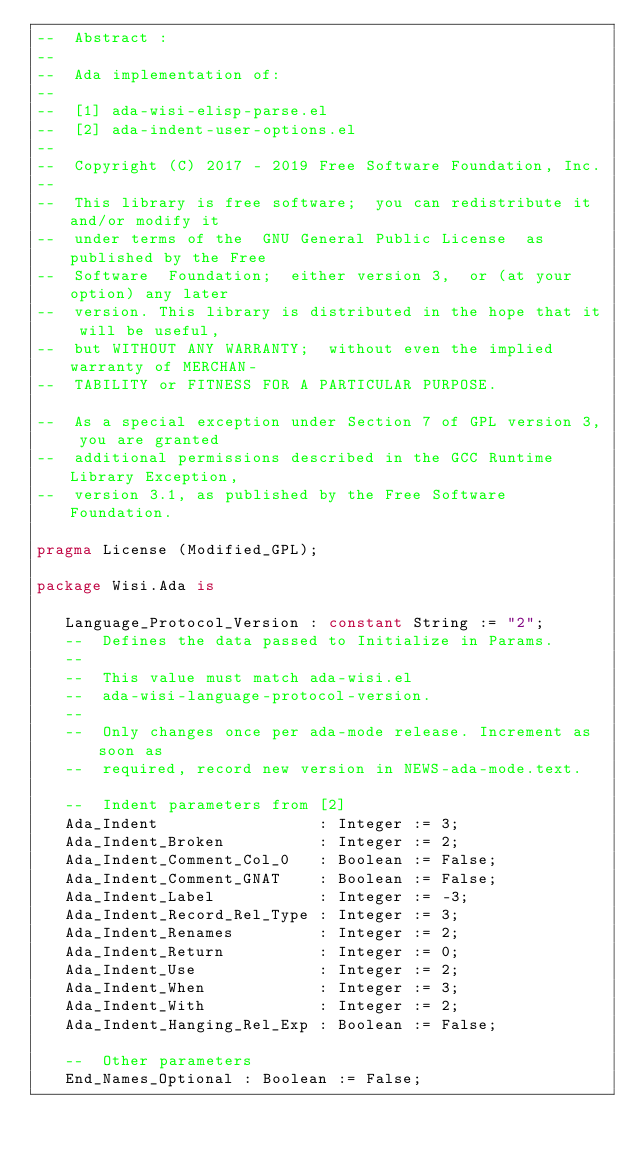<code> <loc_0><loc_0><loc_500><loc_500><_Ada_>--  Abstract :
--
--  Ada implementation of:
--
--  [1] ada-wisi-elisp-parse.el
--  [2] ada-indent-user-options.el
--
--  Copyright (C) 2017 - 2019 Free Software Foundation, Inc.
--
--  This library is free software;  you can redistribute it and/or modify it
--  under terms of the  GNU General Public License  as published by the Free
--  Software  Foundation;  either version 3,  or (at your  option) any later
--  version. This library is distributed in the hope that it will be useful,
--  but WITHOUT ANY WARRANTY;  without even the implied warranty of MERCHAN-
--  TABILITY or FITNESS FOR A PARTICULAR PURPOSE.

--  As a special exception under Section 7 of GPL version 3, you are granted
--  additional permissions described in the GCC Runtime Library Exception,
--  version 3.1, as published by the Free Software Foundation.

pragma License (Modified_GPL);

package Wisi.Ada is

   Language_Protocol_Version : constant String := "2";
   --  Defines the data passed to Initialize in Params.
   --
   --  This value must match ada-wisi.el
   --  ada-wisi-language-protocol-version.
   --
   --  Only changes once per ada-mode release. Increment as soon as
   --  required, record new version in NEWS-ada-mode.text.

   --  Indent parameters from [2]
   Ada_Indent                 : Integer := 3;
   Ada_Indent_Broken          : Integer := 2;
   Ada_Indent_Comment_Col_0   : Boolean := False;
   Ada_Indent_Comment_GNAT    : Boolean := False;
   Ada_Indent_Label           : Integer := -3;
   Ada_Indent_Record_Rel_Type : Integer := 3;
   Ada_Indent_Renames         : Integer := 2;
   Ada_Indent_Return          : Integer := 0;
   Ada_Indent_Use             : Integer := 2;
   Ada_Indent_When            : Integer := 3;
   Ada_Indent_With            : Integer := 2;
   Ada_Indent_Hanging_Rel_Exp : Boolean := False;

   --  Other parameters
   End_Names_Optional : Boolean := False;
</code> 